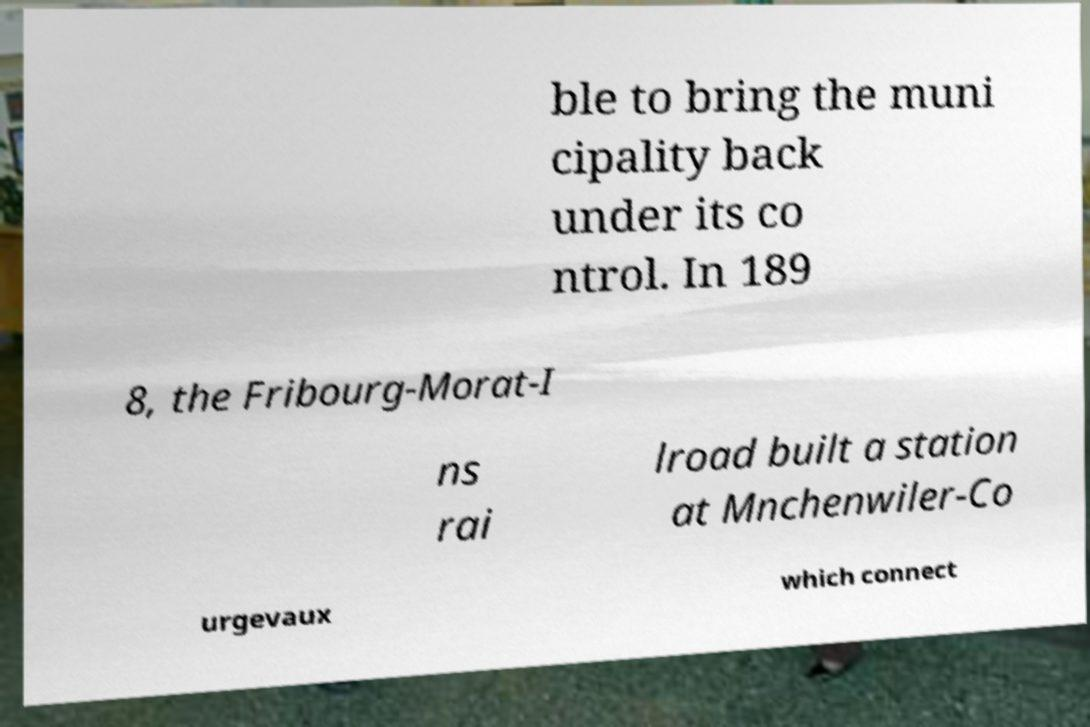Please identify and transcribe the text found in this image. ble to bring the muni cipality back under its co ntrol. In 189 8, the Fribourg-Morat-I ns rai lroad built a station at Mnchenwiler-Co urgevaux which connect 